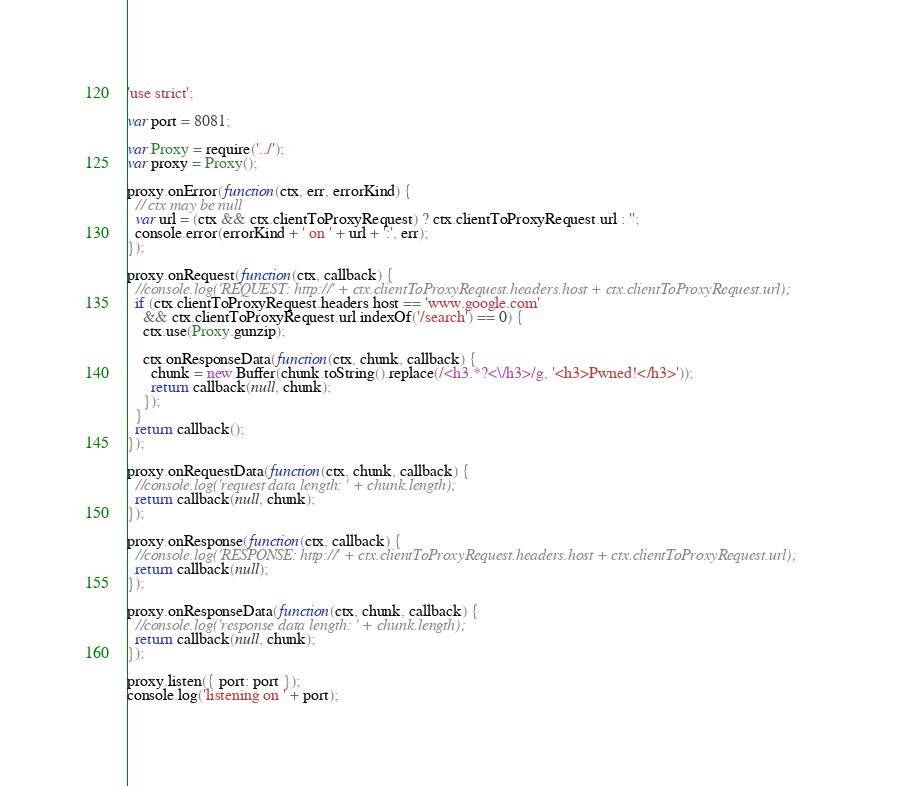Convert code to text. <code><loc_0><loc_0><loc_500><loc_500><_JavaScript_>'use strict';

var port = 8081;

var Proxy = require('../');
var proxy = Proxy();

proxy.onError(function(ctx, err, errorKind) {
  // ctx may be null
  var url = (ctx && ctx.clientToProxyRequest) ? ctx.clientToProxyRequest.url : '';
  console.error(errorKind + ' on ' + url + ':', err);
});

proxy.onRequest(function(ctx, callback) {
  //console.log('REQUEST: http://' + ctx.clientToProxyRequest.headers.host + ctx.clientToProxyRequest.url);
  if (ctx.clientToProxyRequest.headers.host == 'www.google.com'
    && ctx.clientToProxyRequest.url.indexOf('/search') == 0) {
    ctx.use(Proxy.gunzip);

    ctx.onResponseData(function(ctx, chunk, callback) {
      chunk = new Buffer(chunk.toString().replace(/<h3.*?<\/h3>/g, '<h3>Pwned!</h3>'));
      return callback(null, chunk);
    });
  }
  return callback();
});

proxy.onRequestData(function(ctx, chunk, callback) {
  //console.log('request data length: ' + chunk.length);
  return callback(null, chunk);
});

proxy.onResponse(function(ctx, callback) {
  //console.log('RESPONSE: http://' + ctx.clientToProxyRequest.headers.host + ctx.clientToProxyRequest.url);
  return callback(null);
});

proxy.onResponseData(function(ctx, chunk, callback) {
  //console.log('response data length: ' + chunk.length);
  return callback(null, chunk);
});

proxy.listen({ port: port });
console.log('listening on ' + port);
</code> 